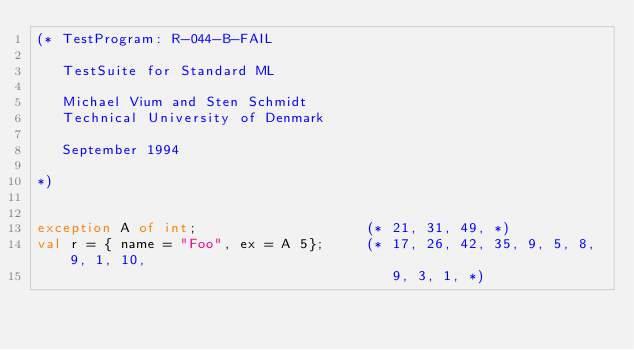<code> <loc_0><loc_0><loc_500><loc_500><_SML_>(* TestProgram: R-044-B-FAIL

   TestSuite for Standard ML

   Michael Vium and Sten Schmidt
   Technical University of Denmark

   September 1994

*)


exception A of int;                    (* 21, 31, 49, *)
val r = { name = "Foo", ex = A 5};     (* 17, 26, 42, 35, 9, 5, 8, 9, 1, 10,
                                          9, 3, 1, *)</code> 